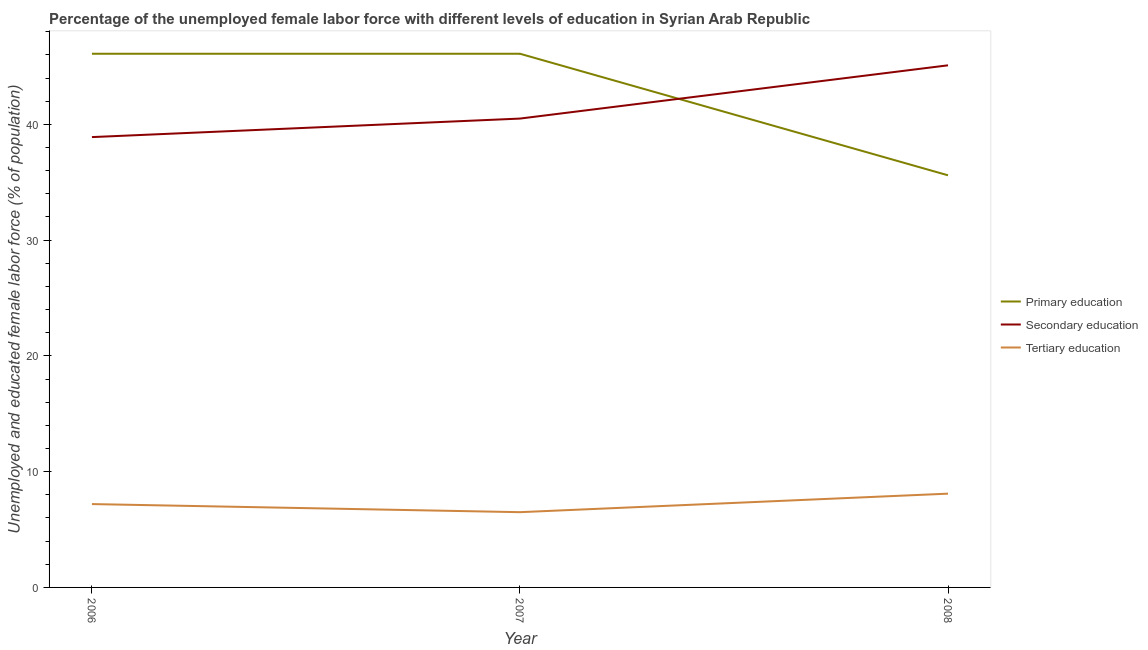How many different coloured lines are there?
Offer a very short reply. 3. Is the number of lines equal to the number of legend labels?
Provide a short and direct response. Yes. What is the percentage of female labor force who received secondary education in 2007?
Your answer should be very brief. 40.5. Across all years, what is the maximum percentage of female labor force who received primary education?
Provide a succinct answer. 46.1. Across all years, what is the minimum percentage of female labor force who received primary education?
Make the answer very short. 35.6. What is the total percentage of female labor force who received tertiary education in the graph?
Provide a short and direct response. 21.8. What is the difference between the percentage of female labor force who received tertiary education in 2006 and that in 2008?
Make the answer very short. -0.9. What is the difference between the percentage of female labor force who received secondary education in 2008 and the percentage of female labor force who received tertiary education in 2006?
Keep it short and to the point. 37.9. What is the average percentage of female labor force who received tertiary education per year?
Provide a succinct answer. 7.27. In the year 2006, what is the difference between the percentage of female labor force who received secondary education and percentage of female labor force who received tertiary education?
Provide a short and direct response. 31.7. In how many years, is the percentage of female labor force who received secondary education greater than 20 %?
Provide a succinct answer. 3. What is the ratio of the percentage of female labor force who received secondary education in 2006 to that in 2007?
Keep it short and to the point. 0.96. Is the percentage of female labor force who received secondary education in 2006 less than that in 2007?
Give a very brief answer. Yes. Is the difference between the percentage of female labor force who received tertiary education in 2006 and 2008 greater than the difference between the percentage of female labor force who received primary education in 2006 and 2008?
Keep it short and to the point. No. What is the difference between the highest and the lowest percentage of female labor force who received secondary education?
Offer a very short reply. 6.2. Is the sum of the percentage of female labor force who received secondary education in 2007 and 2008 greater than the maximum percentage of female labor force who received tertiary education across all years?
Give a very brief answer. Yes. Does the percentage of female labor force who received primary education monotonically increase over the years?
Offer a terse response. No. Is the percentage of female labor force who received tertiary education strictly greater than the percentage of female labor force who received primary education over the years?
Make the answer very short. No. Is the percentage of female labor force who received secondary education strictly less than the percentage of female labor force who received primary education over the years?
Offer a terse response. No. How many lines are there?
Offer a terse response. 3. Does the graph contain grids?
Offer a terse response. No. Where does the legend appear in the graph?
Offer a terse response. Center right. How many legend labels are there?
Your answer should be compact. 3. What is the title of the graph?
Your answer should be very brief. Percentage of the unemployed female labor force with different levels of education in Syrian Arab Republic. Does "Social Protection and Labor" appear as one of the legend labels in the graph?
Your answer should be compact. No. What is the label or title of the X-axis?
Offer a very short reply. Year. What is the label or title of the Y-axis?
Your answer should be very brief. Unemployed and educated female labor force (% of population). What is the Unemployed and educated female labor force (% of population) of Primary education in 2006?
Keep it short and to the point. 46.1. What is the Unemployed and educated female labor force (% of population) in Secondary education in 2006?
Ensure brevity in your answer.  38.9. What is the Unemployed and educated female labor force (% of population) in Tertiary education in 2006?
Ensure brevity in your answer.  7.2. What is the Unemployed and educated female labor force (% of population) in Primary education in 2007?
Offer a terse response. 46.1. What is the Unemployed and educated female labor force (% of population) of Secondary education in 2007?
Your response must be concise. 40.5. What is the Unemployed and educated female labor force (% of population) in Primary education in 2008?
Your response must be concise. 35.6. What is the Unemployed and educated female labor force (% of population) of Secondary education in 2008?
Your response must be concise. 45.1. What is the Unemployed and educated female labor force (% of population) of Tertiary education in 2008?
Your response must be concise. 8.1. Across all years, what is the maximum Unemployed and educated female labor force (% of population) of Primary education?
Make the answer very short. 46.1. Across all years, what is the maximum Unemployed and educated female labor force (% of population) in Secondary education?
Your answer should be very brief. 45.1. Across all years, what is the maximum Unemployed and educated female labor force (% of population) in Tertiary education?
Ensure brevity in your answer.  8.1. Across all years, what is the minimum Unemployed and educated female labor force (% of population) of Primary education?
Give a very brief answer. 35.6. Across all years, what is the minimum Unemployed and educated female labor force (% of population) in Secondary education?
Offer a very short reply. 38.9. Across all years, what is the minimum Unemployed and educated female labor force (% of population) in Tertiary education?
Offer a terse response. 6.5. What is the total Unemployed and educated female labor force (% of population) in Primary education in the graph?
Keep it short and to the point. 127.8. What is the total Unemployed and educated female labor force (% of population) of Secondary education in the graph?
Your answer should be very brief. 124.5. What is the total Unemployed and educated female labor force (% of population) in Tertiary education in the graph?
Give a very brief answer. 21.8. What is the difference between the Unemployed and educated female labor force (% of population) of Tertiary education in 2006 and that in 2007?
Offer a very short reply. 0.7. What is the difference between the Unemployed and educated female labor force (% of population) of Tertiary education in 2006 and that in 2008?
Make the answer very short. -0.9. What is the difference between the Unemployed and educated female labor force (% of population) of Secondary education in 2007 and that in 2008?
Offer a very short reply. -4.6. What is the difference between the Unemployed and educated female labor force (% of population) of Primary education in 2006 and the Unemployed and educated female labor force (% of population) of Secondary education in 2007?
Give a very brief answer. 5.6. What is the difference between the Unemployed and educated female labor force (% of population) in Primary education in 2006 and the Unemployed and educated female labor force (% of population) in Tertiary education in 2007?
Keep it short and to the point. 39.6. What is the difference between the Unemployed and educated female labor force (% of population) in Secondary education in 2006 and the Unemployed and educated female labor force (% of population) in Tertiary education in 2007?
Provide a short and direct response. 32.4. What is the difference between the Unemployed and educated female labor force (% of population) in Primary education in 2006 and the Unemployed and educated female labor force (% of population) in Secondary education in 2008?
Offer a terse response. 1. What is the difference between the Unemployed and educated female labor force (% of population) of Secondary education in 2006 and the Unemployed and educated female labor force (% of population) of Tertiary education in 2008?
Make the answer very short. 30.8. What is the difference between the Unemployed and educated female labor force (% of population) of Primary education in 2007 and the Unemployed and educated female labor force (% of population) of Tertiary education in 2008?
Your response must be concise. 38. What is the difference between the Unemployed and educated female labor force (% of population) of Secondary education in 2007 and the Unemployed and educated female labor force (% of population) of Tertiary education in 2008?
Your response must be concise. 32.4. What is the average Unemployed and educated female labor force (% of population) of Primary education per year?
Offer a very short reply. 42.6. What is the average Unemployed and educated female labor force (% of population) in Secondary education per year?
Provide a short and direct response. 41.5. What is the average Unemployed and educated female labor force (% of population) in Tertiary education per year?
Provide a succinct answer. 7.27. In the year 2006, what is the difference between the Unemployed and educated female labor force (% of population) in Primary education and Unemployed and educated female labor force (% of population) in Secondary education?
Ensure brevity in your answer.  7.2. In the year 2006, what is the difference between the Unemployed and educated female labor force (% of population) in Primary education and Unemployed and educated female labor force (% of population) in Tertiary education?
Provide a short and direct response. 38.9. In the year 2006, what is the difference between the Unemployed and educated female labor force (% of population) in Secondary education and Unemployed and educated female labor force (% of population) in Tertiary education?
Your response must be concise. 31.7. In the year 2007, what is the difference between the Unemployed and educated female labor force (% of population) of Primary education and Unemployed and educated female labor force (% of population) of Tertiary education?
Make the answer very short. 39.6. In the year 2008, what is the difference between the Unemployed and educated female labor force (% of population) in Primary education and Unemployed and educated female labor force (% of population) in Tertiary education?
Ensure brevity in your answer.  27.5. In the year 2008, what is the difference between the Unemployed and educated female labor force (% of population) of Secondary education and Unemployed and educated female labor force (% of population) of Tertiary education?
Provide a short and direct response. 37. What is the ratio of the Unemployed and educated female labor force (% of population) in Secondary education in 2006 to that in 2007?
Keep it short and to the point. 0.96. What is the ratio of the Unemployed and educated female labor force (% of population) of Tertiary education in 2006 to that in 2007?
Give a very brief answer. 1.11. What is the ratio of the Unemployed and educated female labor force (% of population) of Primary education in 2006 to that in 2008?
Your response must be concise. 1.29. What is the ratio of the Unemployed and educated female labor force (% of population) in Secondary education in 2006 to that in 2008?
Make the answer very short. 0.86. What is the ratio of the Unemployed and educated female labor force (% of population) in Primary education in 2007 to that in 2008?
Offer a terse response. 1.29. What is the ratio of the Unemployed and educated female labor force (% of population) of Secondary education in 2007 to that in 2008?
Provide a succinct answer. 0.9. What is the ratio of the Unemployed and educated female labor force (% of population) of Tertiary education in 2007 to that in 2008?
Offer a very short reply. 0.8. What is the difference between the highest and the lowest Unemployed and educated female labor force (% of population) of Primary education?
Your answer should be very brief. 10.5. What is the difference between the highest and the lowest Unemployed and educated female labor force (% of population) in Secondary education?
Keep it short and to the point. 6.2. What is the difference between the highest and the lowest Unemployed and educated female labor force (% of population) of Tertiary education?
Your response must be concise. 1.6. 